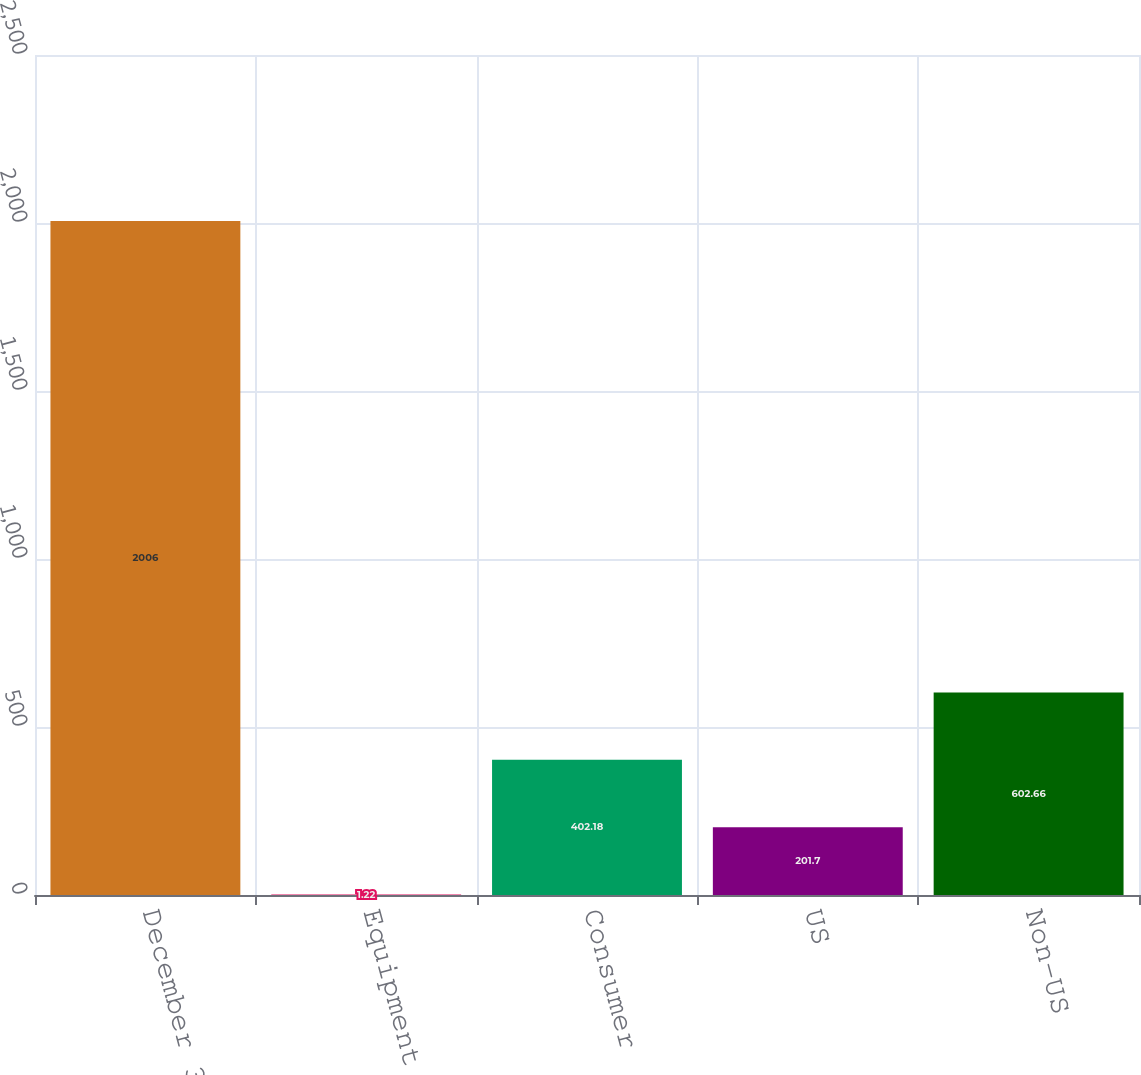Convert chart to OTSL. <chart><loc_0><loc_0><loc_500><loc_500><bar_chart><fcel>December 31<fcel>Equipment financing<fcel>Consumer<fcel>US<fcel>Non-US<nl><fcel>2006<fcel>1.22<fcel>402.18<fcel>201.7<fcel>602.66<nl></chart> 